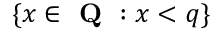Convert formula to latex. <formula><loc_0><loc_0><loc_500><loc_500>\{ x \in { Q } \colon x < q \}</formula> 